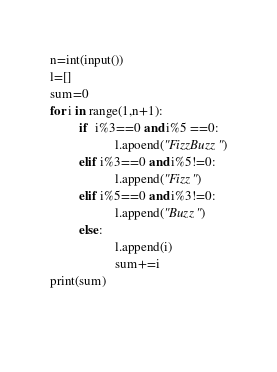<code> <loc_0><loc_0><loc_500><loc_500><_Python_>n=int(input())
l=[]
sum=0
for i in range(1,n+1):
         if  i%3==0 and i%5 ==0:
                    l.apoend("FizzBuzz")
         elif i%3==0 and i%5!=0:
                    l.append("Fizz")
         elif i%5==0 and i%3!=0:
                    l.append("Buzz")
         else:
                    l.append(i)
                    sum+=i
print(sum)
         
                   
</code> 